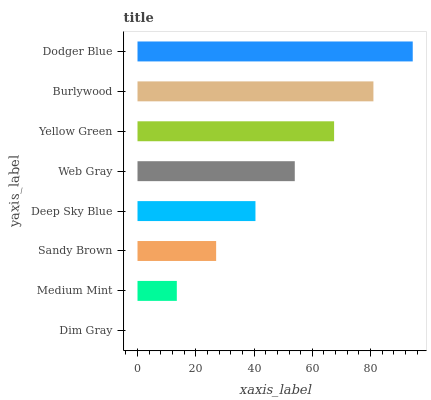Is Dim Gray the minimum?
Answer yes or no. Yes. Is Dodger Blue the maximum?
Answer yes or no. Yes. Is Medium Mint the minimum?
Answer yes or no. No. Is Medium Mint the maximum?
Answer yes or no. No. Is Medium Mint greater than Dim Gray?
Answer yes or no. Yes. Is Dim Gray less than Medium Mint?
Answer yes or no. Yes. Is Dim Gray greater than Medium Mint?
Answer yes or no. No. Is Medium Mint less than Dim Gray?
Answer yes or no. No. Is Web Gray the high median?
Answer yes or no. Yes. Is Deep Sky Blue the low median?
Answer yes or no. Yes. Is Sandy Brown the high median?
Answer yes or no. No. Is Web Gray the low median?
Answer yes or no. No. 